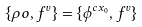Convert formula to latex. <formula><loc_0><loc_0><loc_500><loc_500>\{ \rho o , f ^ { v } \} = \{ \phi ^ { c x _ { 0 } } , f ^ { v } \}</formula> 